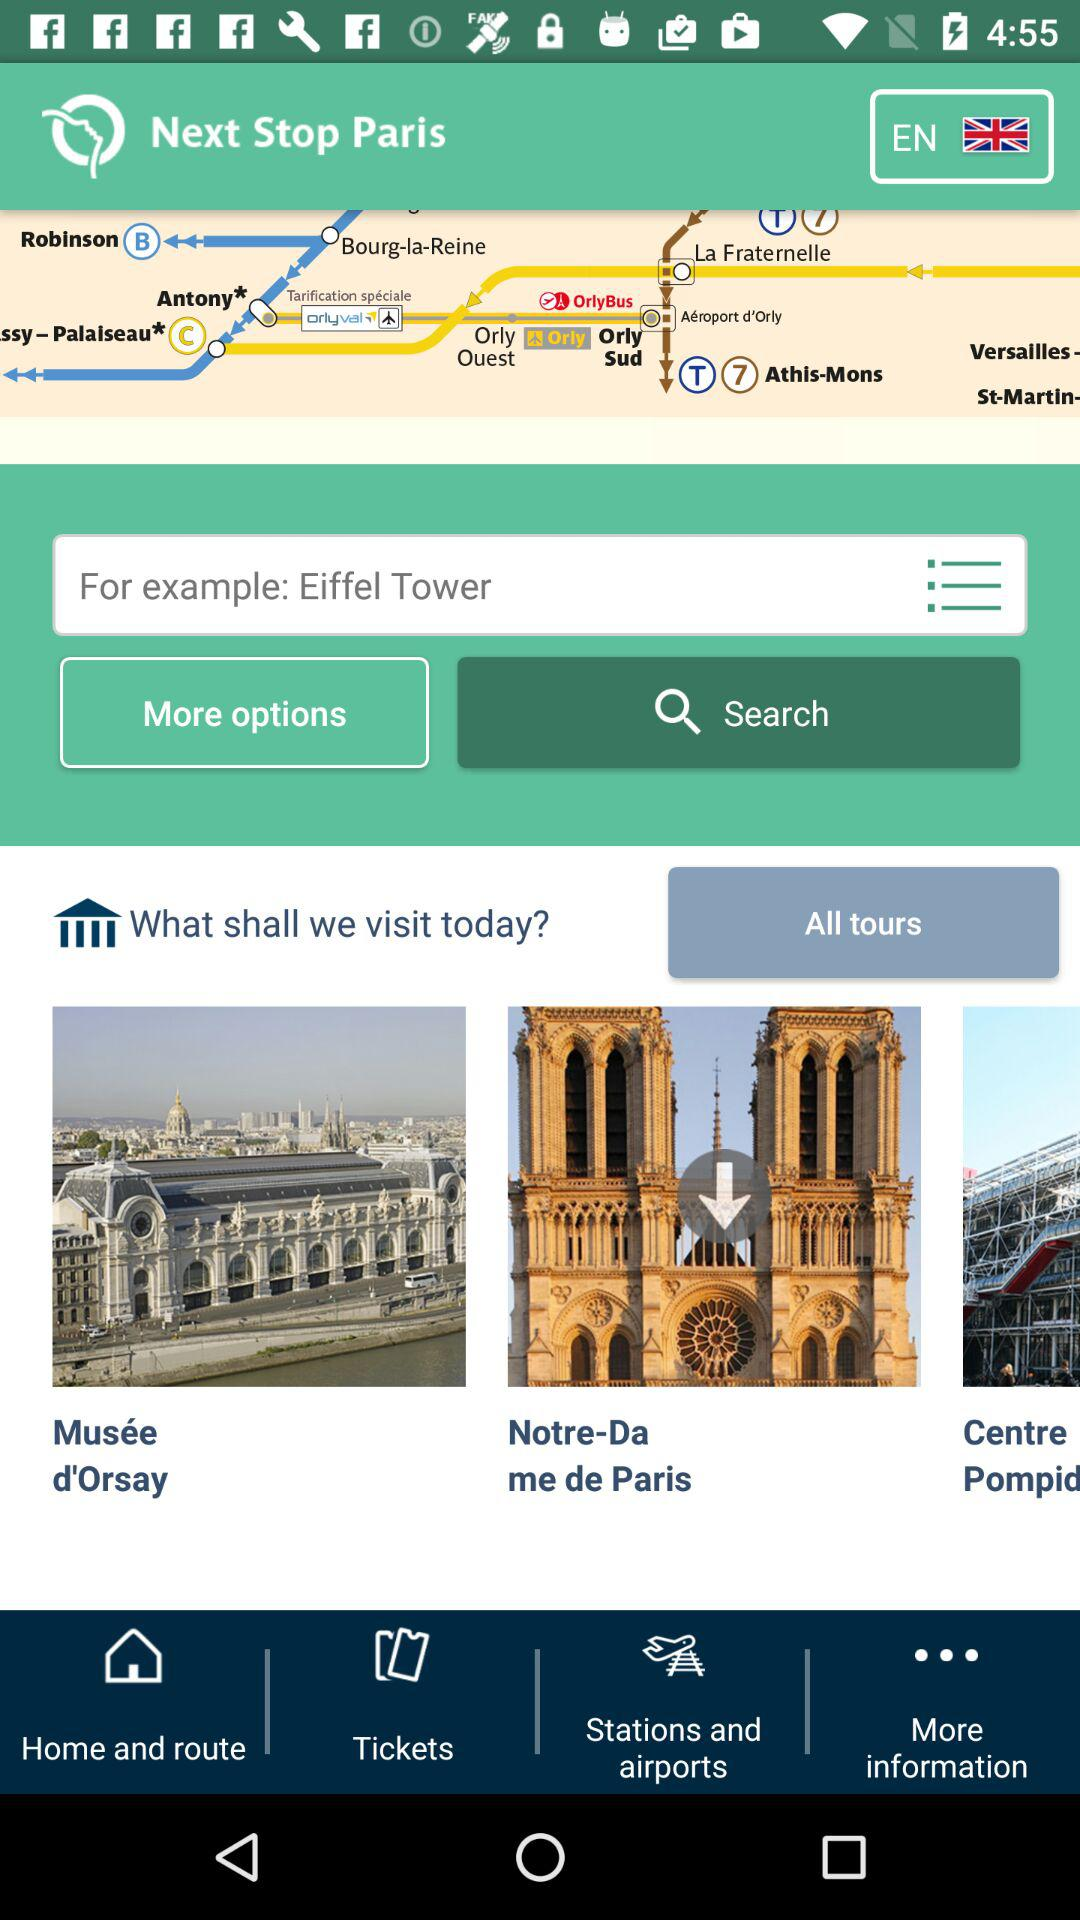What is the given example? The given example is the Eiffel Tower. 